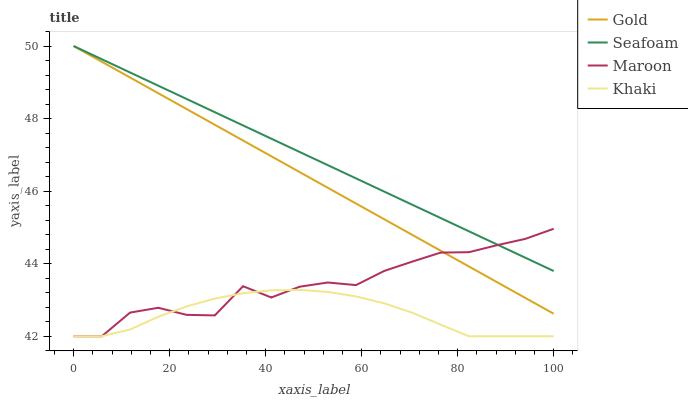Does Khaki have the minimum area under the curve?
Answer yes or no. Yes. Does Seafoam have the maximum area under the curve?
Answer yes or no. Yes. Does Seafoam have the minimum area under the curve?
Answer yes or no. No. Does Khaki have the maximum area under the curve?
Answer yes or no. No. Is Seafoam the smoothest?
Answer yes or no. Yes. Is Maroon the roughest?
Answer yes or no. Yes. Is Khaki the smoothest?
Answer yes or no. No. Is Khaki the roughest?
Answer yes or no. No. Does Maroon have the lowest value?
Answer yes or no. Yes. Does Seafoam have the lowest value?
Answer yes or no. No. Does Gold have the highest value?
Answer yes or no. Yes. Does Khaki have the highest value?
Answer yes or no. No. Is Khaki less than Gold?
Answer yes or no. Yes. Is Gold greater than Khaki?
Answer yes or no. Yes. Does Seafoam intersect Gold?
Answer yes or no. Yes. Is Seafoam less than Gold?
Answer yes or no. No. Is Seafoam greater than Gold?
Answer yes or no. No. Does Khaki intersect Gold?
Answer yes or no. No. 